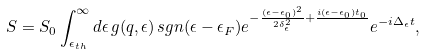<formula> <loc_0><loc_0><loc_500><loc_500>S = S _ { 0 } \int _ { \epsilon _ { t h } } ^ { \infty } d \epsilon \, g ( q , \epsilon ) \, s g n ( \epsilon - \epsilon _ { F } ) e ^ { - \frac { ( \epsilon - \epsilon _ { 0 } ) ^ { 2 } } { 2 \delta ^ { 2 } _ { \epsilon } } + \frac { i ( \epsilon - \epsilon _ { 0 } ) t _ { 0 } } { } } e ^ { - i \Delta _ { \epsilon } t } ,</formula> 